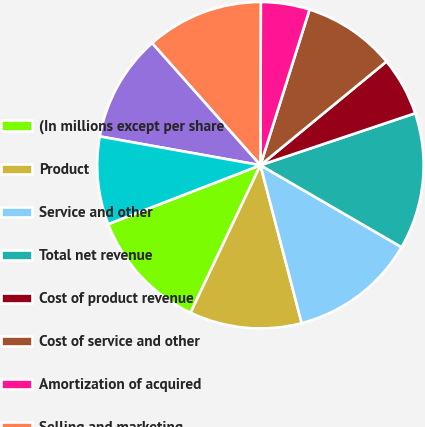<chart> <loc_0><loc_0><loc_500><loc_500><pie_chart><fcel>(In millions except per share<fcel>Product<fcel>Service and other<fcel>Total net revenue<fcel>Cost of product revenue<fcel>Cost of service and other<fcel>Amortization of acquired<fcel>Selling and marketing<fcel>Research and development<fcel>General and administrative<nl><fcel>12.08%<fcel>11.11%<fcel>12.56%<fcel>13.53%<fcel>5.8%<fcel>9.18%<fcel>4.83%<fcel>11.59%<fcel>10.63%<fcel>8.7%<nl></chart> 